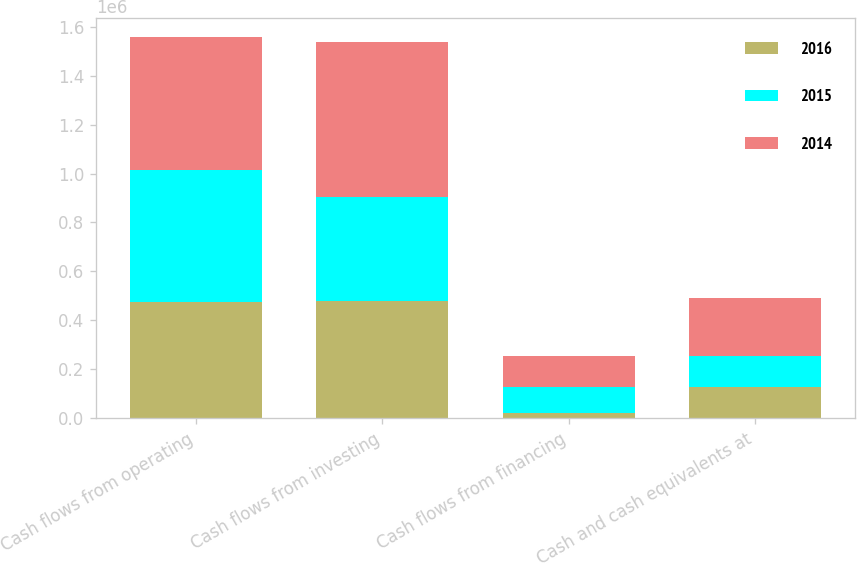Convert chart. <chart><loc_0><loc_0><loc_500><loc_500><stacked_bar_chart><ecel><fcel>Cash flows from operating<fcel>Cash flows from investing<fcel>Cash flows from financing<fcel>Cash and cash equivalents at<nl><fcel>2016<fcel>472948<fcel>479978<fcel>19857<fcel>125933<nl><fcel>2015<fcel>541760<fcel>422786<fcel>108511<fcel>128381<nl><fcel>2014<fcel>541216<fcel>632703<fcel>125373<fcel>236484<nl></chart> 